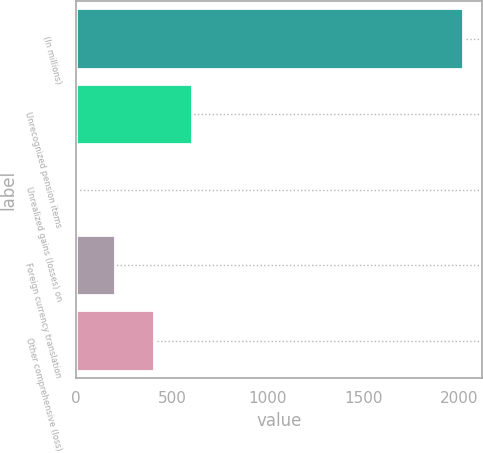Convert chart. <chart><loc_0><loc_0><loc_500><loc_500><bar_chart><fcel>(In millions)<fcel>Unrecognized pension items<fcel>Unrealized gains (losses) on<fcel>Foreign currency translation<fcel>Other comprehensive (loss)<nl><fcel>2018<fcel>606.24<fcel>1.2<fcel>202.88<fcel>404.56<nl></chart> 